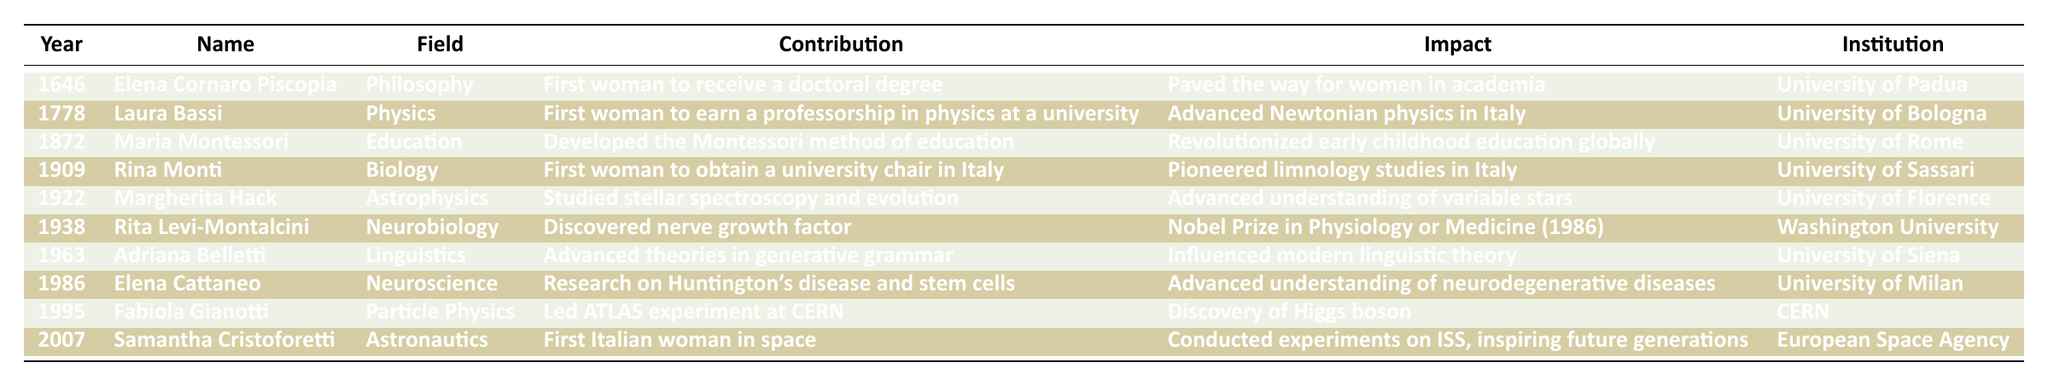What year did Elena Cornaro Piscopia receive her doctoral degree? The table shows that Elena Cornaro Piscopia received her doctoral degree in the year 1646.
Answer: 1646 Who was the first woman to earn a professorship in physics according to the table? The table identifies Laura Bassi as the first woman to earn a professorship in physics at a university, which occurred in 1778.
Answer: Laura Bassi What field did Maria Montessori contribute to? The contribution of Maria Montessori is listed under the field of Education.
Answer: Education How many women listed in the table won a Nobel Prize? Only Rita Levi-Montalcini is noted for winning a Nobel Prize in Physiology or Medicine, which makes it one woman.
Answer: 1 Which institution did Margherita Hack work at? The table specifies that Margherita Hack worked at the University of Florence.
Answer: University of Florence Who made contributions to neuroscience, and what was her achievement? The table states that Elena Cattaneo made contributions to neuroscience, specifically research on Huntington's disease and stem cells.
Answer: Elena Cattaneo, Huntington's disease research Which woman’s work is noted for having a global impact on early childhood education? The table highlights that Maria Montessori's development of the Montessori method of education had a global impact on early childhood education.
Answer: Maria Montessori What was the impact of Rina Monti's contribution? According to the table, Rina Monti pioneered limnology studies in Italy, indicating her significant impact on the study of the biology of freshwater systems.
Answer: Pioneered limnology studies List the names of women who contributed to the field of physics or related sciences. The women in the field of physics or related sciences listed in the table are Laura Bassi and Fabiola Gianotti.
Answer: Laura Bassi, Fabiola Gianotti In what year did Fabiola Gianotti lead the ATLAS experiment at CERN? The table shows that Fabiola Gianotti led the ATLAS experiment at CERN in the year 1995.
Answer: 1995 Which woman's contribution relates to variable stars? The table states that Margherita Hack contributed to the understanding of variable stars through her studies in astrophysics.
Answer: Margherita Hack What is the latest year mentioned for a woman's contribution in the table? The latest year in the table is 2007, when Samantha Cristoforetti became the first Italian woman in space.
Answer: 2007 Does the table show that any woman achieved a significant contribution in the field of linguistics? Yes, the table confirms that Adriana Belletti advanced theories in generative grammar in the field of linguistics.
Answer: Yes Were any contributions made to the field of biology before the 20th century? Yes, Rina Monti made contributions to biology in 1909, which is prior to the 20th century.
Answer: Yes Calculate the range of years covered by the contributions in the table. The first recorded contribution is from 1646 and the last is from 2007. The range is calculated as 2007 - 1646 = 361 years.
Answer: 361 years Who conducted experiments on the International Space Station (ISS)? According to the table, Samantha Cristoforetti conducted experiments on the ISS.
Answer: Samantha Cristoforetti What were the contributions of both Rita Levi-Montalcini and Elena Cattaneo in terms of disease research? Rita Levi-Montalcini discovered nerve growth factor and was awarded a Nobel Prize, while Elena Cattaneo researched Huntington's disease and stem cells, indicating significant contributions to understanding neurodegenerative diseases.
Answer: Rita Levi-Montalcini - nerve growth factor; Elena Cattaneo - Huntington's disease research 